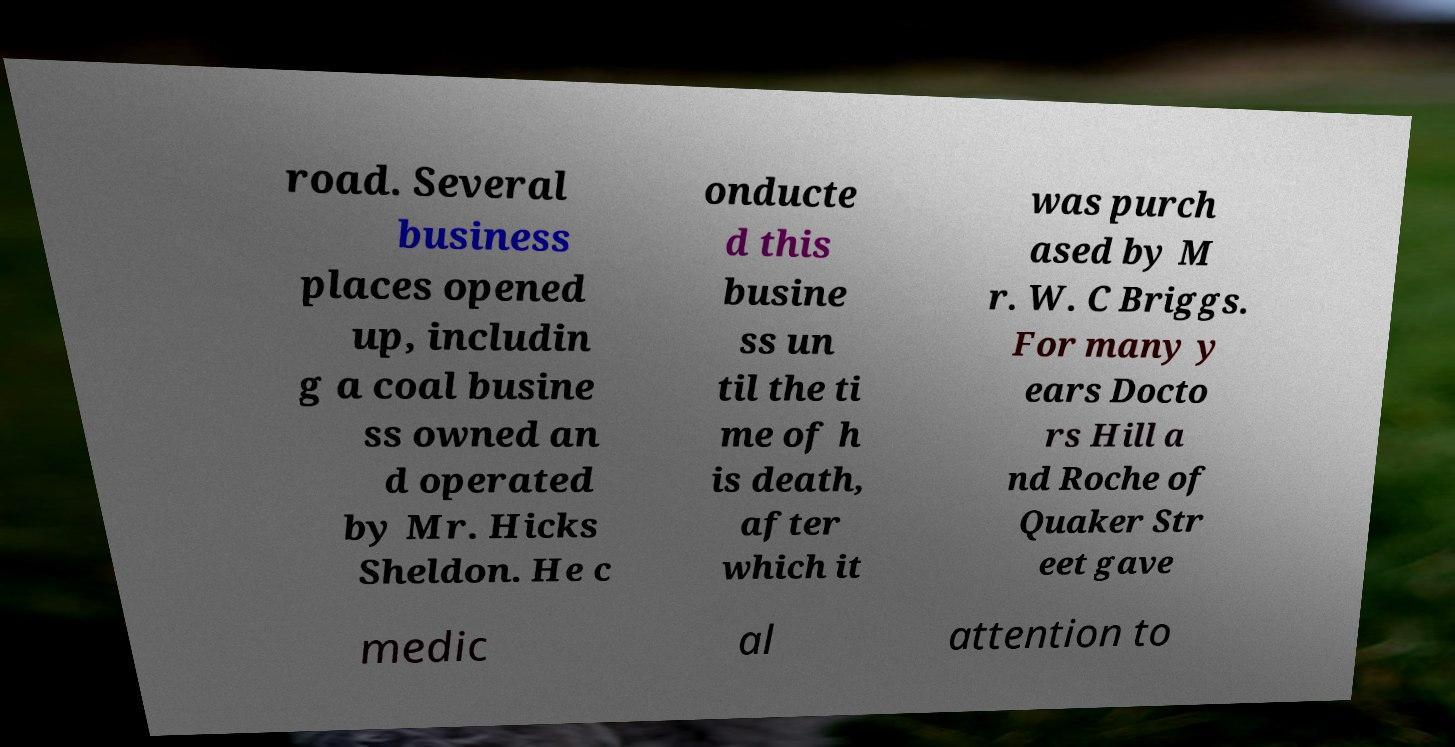Can you accurately transcribe the text from the provided image for me? road. Several business places opened up, includin g a coal busine ss owned an d operated by Mr. Hicks Sheldon. He c onducte d this busine ss un til the ti me of h is death, after which it was purch ased by M r. W. C Briggs. For many y ears Docto rs Hill a nd Roche of Quaker Str eet gave medic al attention to 